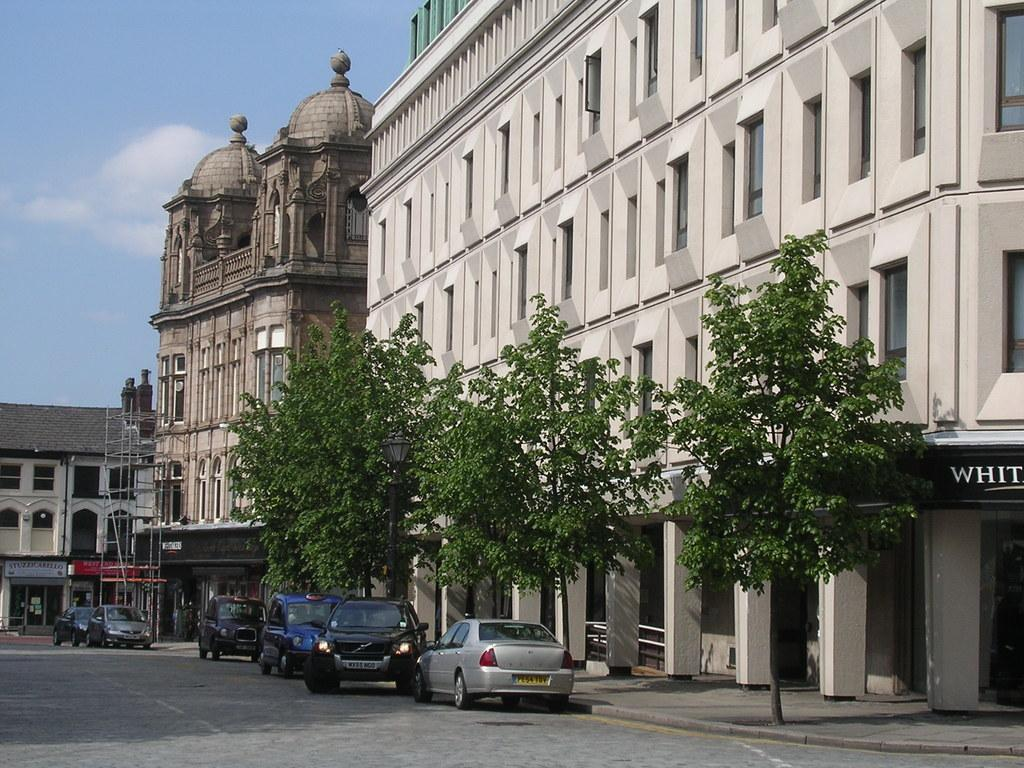What is the main feature of the image? There is a road in the image. What is happening on the road? There are vehicles on the road. What type of vegetation can be seen in the image? There are green trees in the image. What structures are visible in the image? There are buildings in the image. What can be seen in the background of the image? The sky is visible in the background of the image. What type of flowers are being planted during recess in the image? There is no reference to flowers or recess in the image; it features a road, vehicles, green trees, buildings, and the sky. 